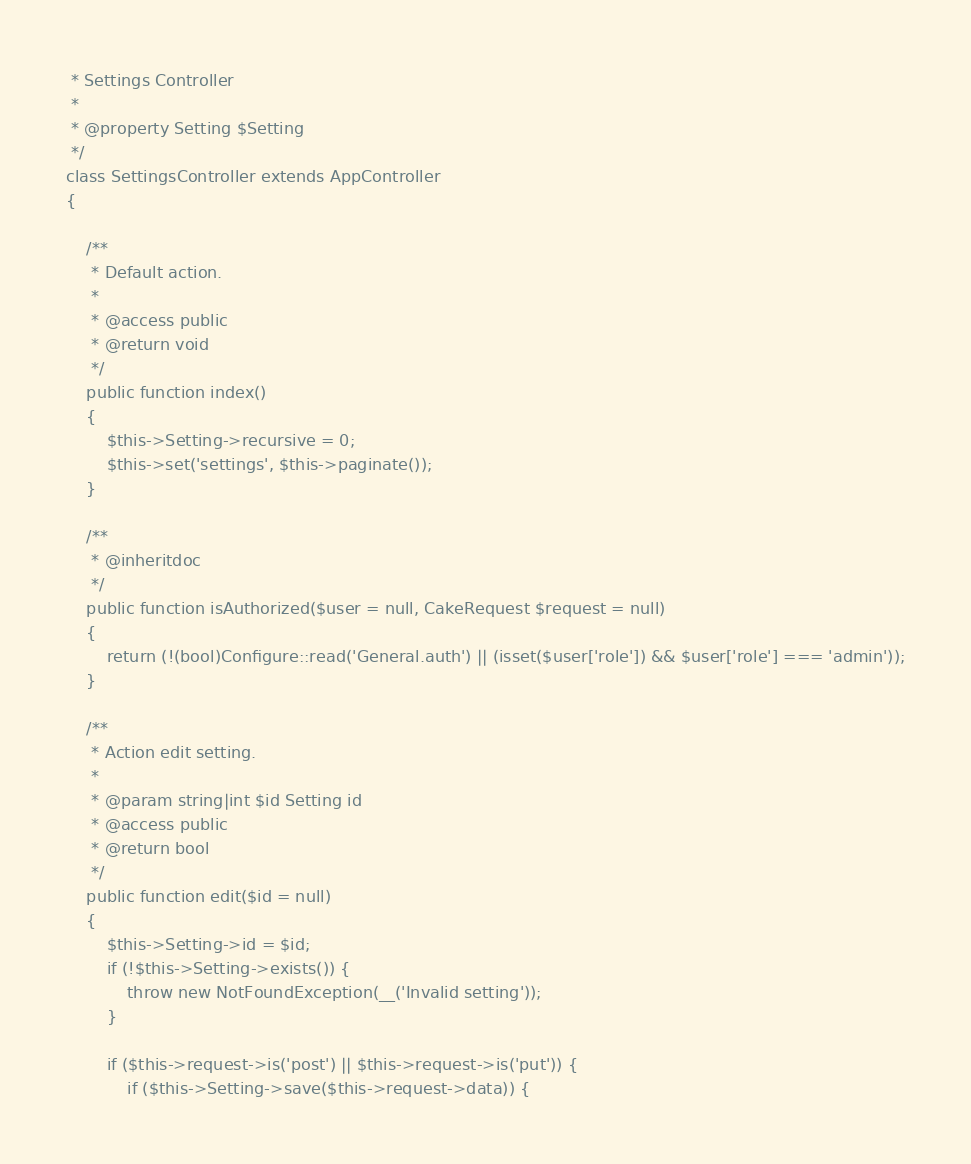Convert code to text. <code><loc_0><loc_0><loc_500><loc_500><_PHP_> * Settings Controller
 *
 * @property Setting $Setting
 */
class SettingsController extends AppController
{

    /**
     * Default action.
     *
     * @access public
     * @return void
     */
    public function index()
    {
        $this->Setting->recursive = 0;
        $this->set('settings', $this->paginate());
    }

    /**
     * @inheritdoc
     */
    public function isAuthorized($user = null, CakeRequest $request = null)
    {
        return (!(bool)Configure::read('General.auth') || (isset($user['role']) && $user['role'] === 'admin'));
    }

    /**
     * Action edit setting.
     *
     * @param string|int $id Setting id
     * @access public
     * @return bool
     */
    public function edit($id = null)
    {
        $this->Setting->id = $id;
        if (!$this->Setting->exists()) {
            throw new NotFoundException(__('Invalid setting'));
        }

        if ($this->request->is('post') || $this->request->is('put')) {
            if ($this->Setting->save($this->request->data)) {</code> 